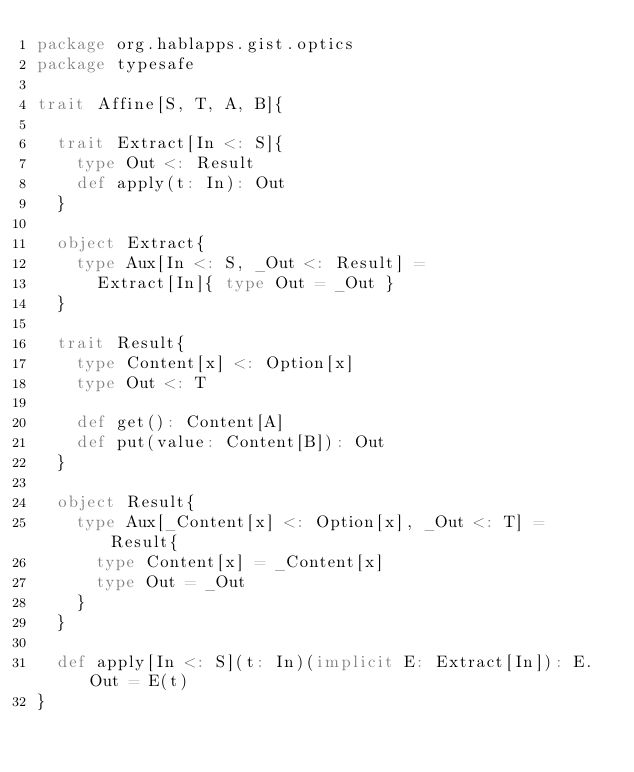<code> <loc_0><loc_0><loc_500><loc_500><_Scala_>package org.hablapps.gist.optics
package typesafe

trait Affine[S, T, A, B]{

  trait Extract[In <: S]{
    type Out <: Result
    def apply(t: In): Out
  }

  object Extract{
    type Aux[In <: S, _Out <: Result] =
      Extract[In]{ type Out = _Out }
  }

  trait Result{
    type Content[x] <: Option[x]
    type Out <: T
    
    def get(): Content[A]
    def put(value: Content[B]): Out
  }

  object Result{
    type Aux[_Content[x] <: Option[x], _Out <: T] = Result{
      type Content[x] = _Content[x]
      type Out = _Out
    }
  }

  def apply[In <: S](t: In)(implicit E: Extract[In]): E.Out = E(t)
}
</code> 